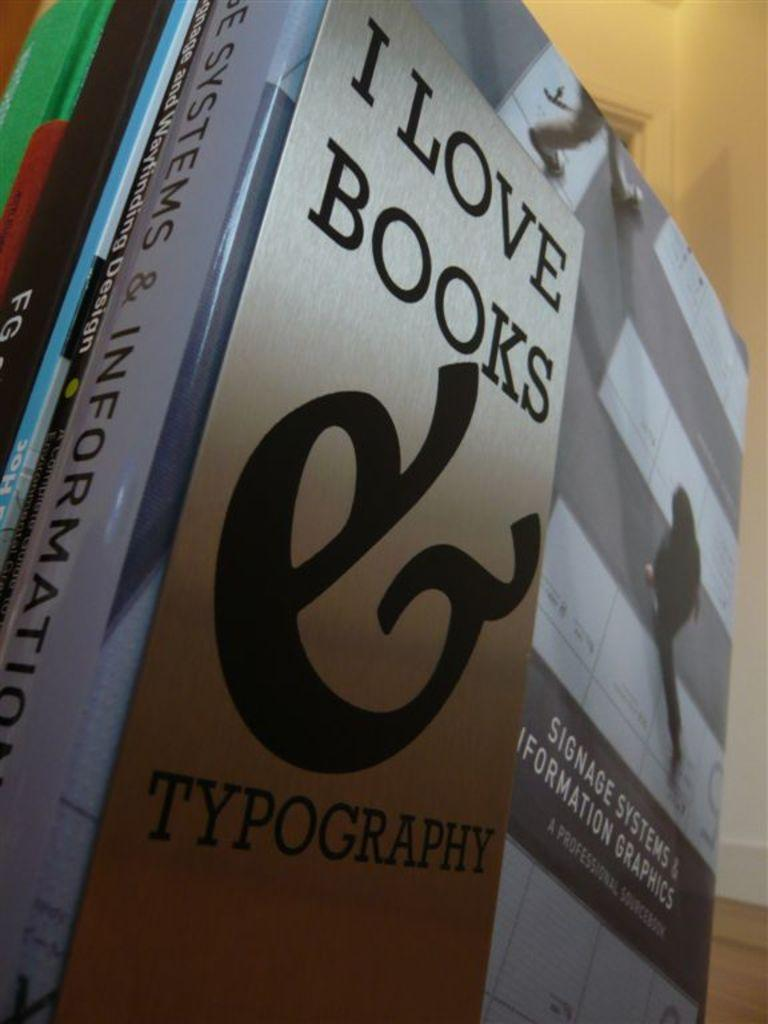<image>
Create a compact narrative representing the image presented. A stack of books a paper titled I Love Books & Typography on top of it. 